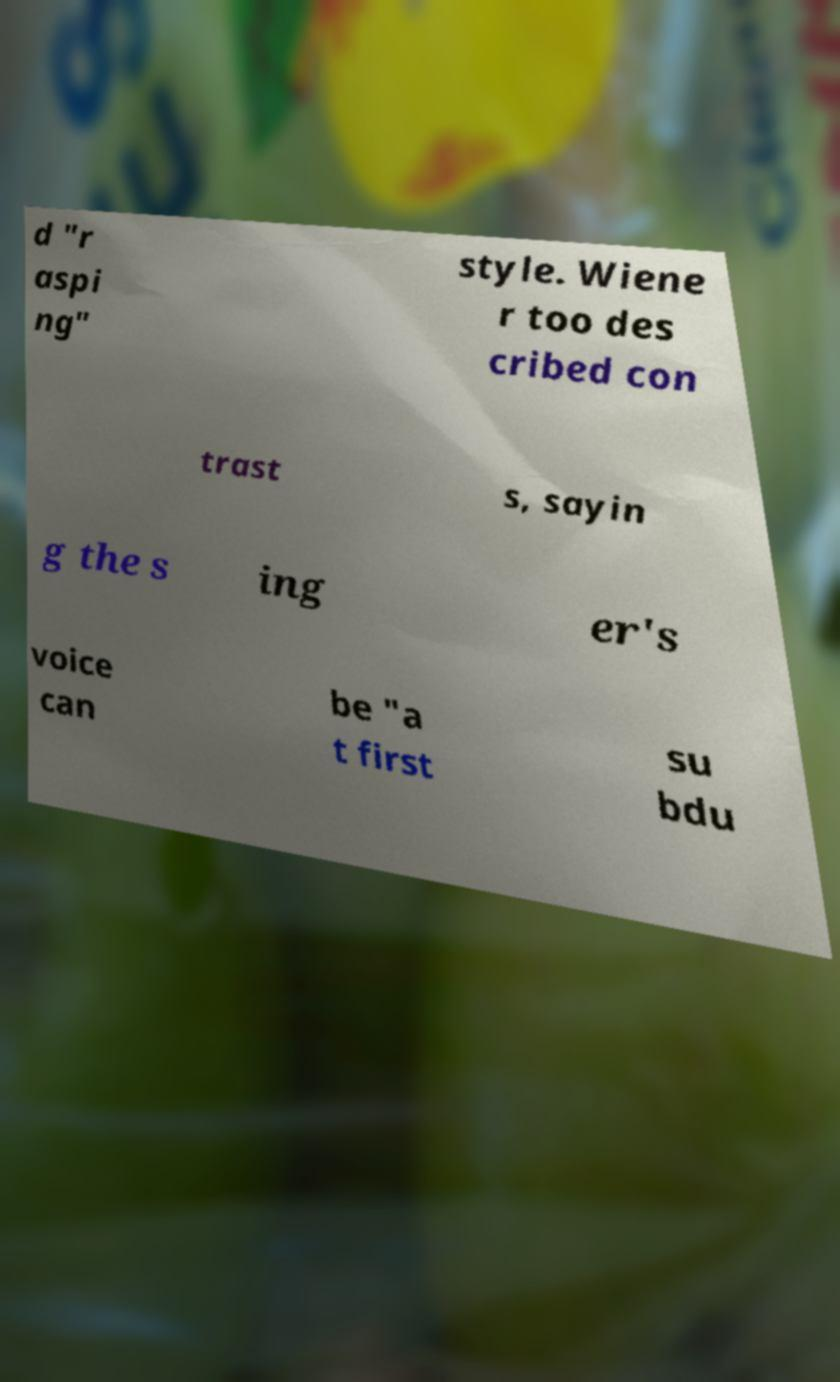There's text embedded in this image that I need extracted. Can you transcribe it verbatim? d "r aspi ng" style. Wiene r too des cribed con trast s, sayin g the s ing er's voice can be "a t first su bdu 